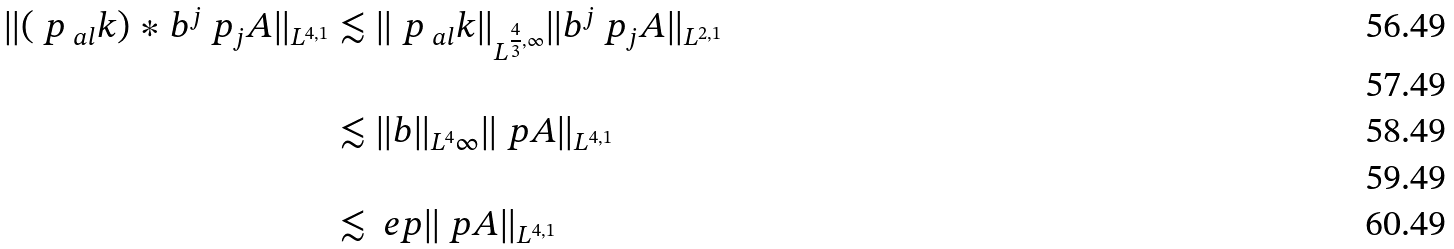<formula> <loc_0><loc_0><loc_500><loc_500>\| ( \ p _ { \ a l } k ) \ast b ^ { j } \ p _ { j } A \| _ { L ^ { 4 , 1 } } & \lesssim \| \ p _ { \ a l } k \| _ { L ^ { \frac { 4 } { 3 } , \infty } } \| b ^ { j } \ p _ { j } A \| _ { L ^ { 2 , 1 } } \\ \\ & \lesssim \| b \| _ { L ^ { 4 } { \infty } } \| \ p A \| _ { L ^ { 4 , 1 } } \\ \\ & \lesssim \ e p \| \ p A \| _ { L ^ { 4 , 1 } }</formula> 